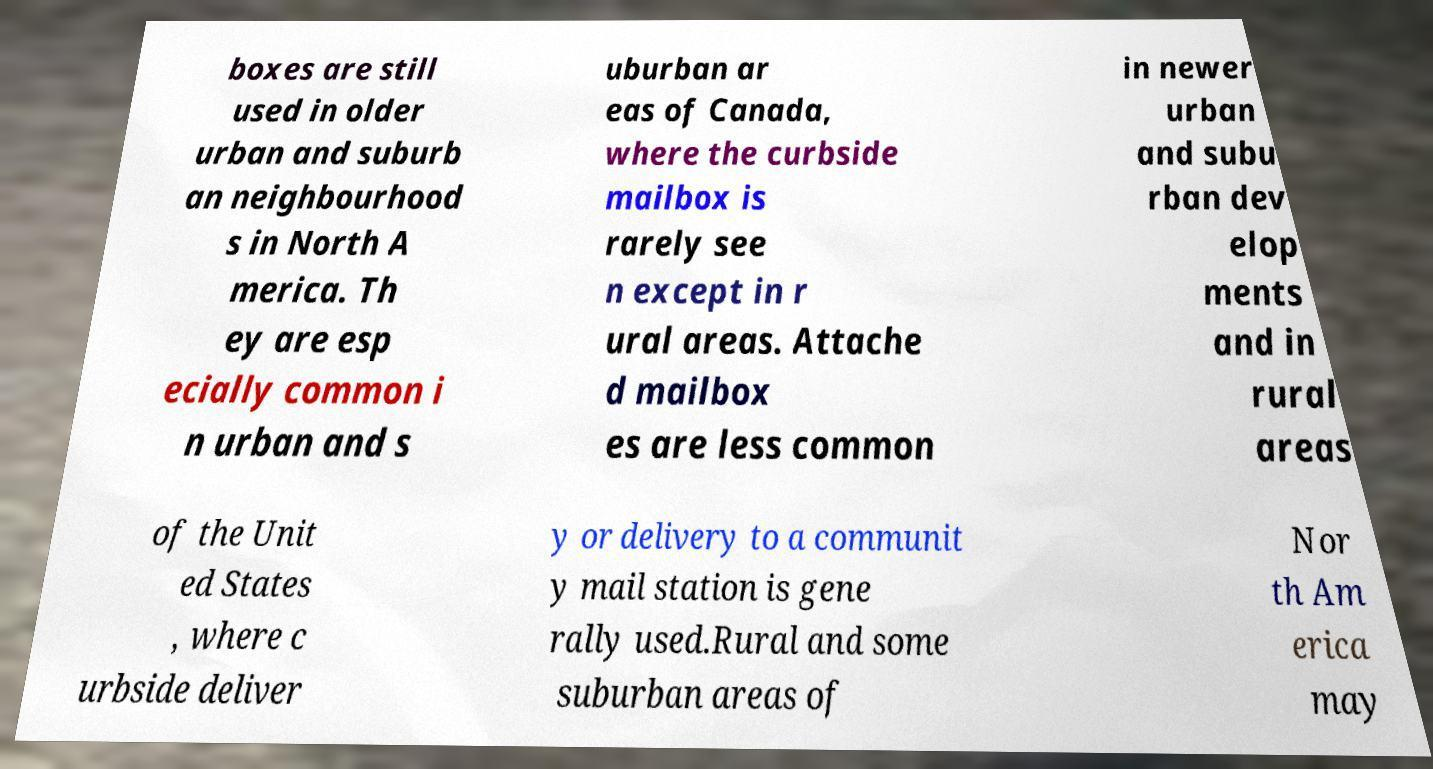What messages or text are displayed in this image? I need them in a readable, typed format. boxes are still used in older urban and suburb an neighbourhood s in North A merica. Th ey are esp ecially common i n urban and s uburban ar eas of Canada, where the curbside mailbox is rarely see n except in r ural areas. Attache d mailbox es are less common in newer urban and subu rban dev elop ments and in rural areas of the Unit ed States , where c urbside deliver y or delivery to a communit y mail station is gene rally used.Rural and some suburban areas of Nor th Am erica may 